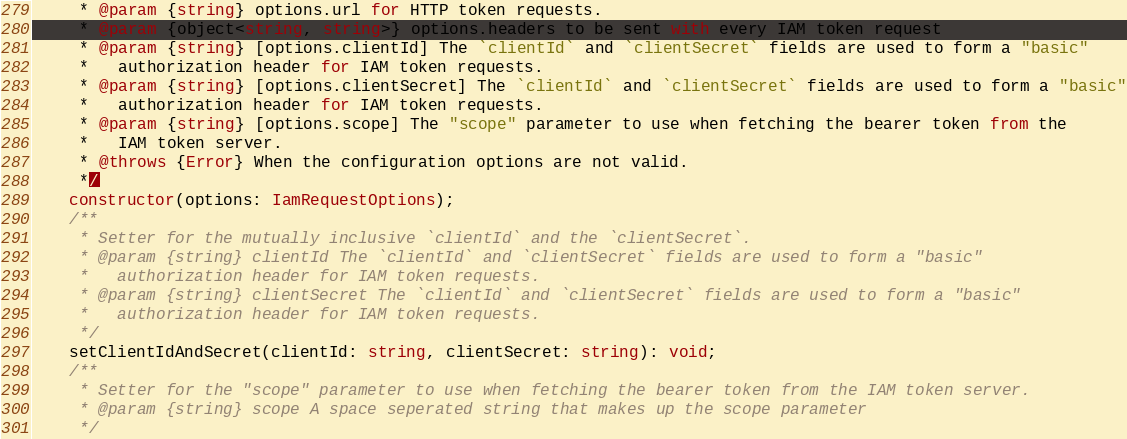Convert code to text. <code><loc_0><loc_0><loc_500><loc_500><_TypeScript_>     * @param {string} options.url for HTTP token requests.
     * @param {object<string, string>} options.headers to be sent with every IAM token request
     * @param {string} [options.clientId] The `clientId` and `clientSecret` fields are used to form a "basic"
     *   authorization header for IAM token requests.
     * @param {string} [options.clientSecret] The `clientId` and `clientSecret` fields are used to form a "basic"
     *   authorization header for IAM token requests.
     * @param {string} [options.scope] The "scope" parameter to use when fetching the bearer token from the
     *   IAM token server.
     * @throws {Error} When the configuration options are not valid.
     */
    constructor(options: IamRequestOptions);
    /**
     * Setter for the mutually inclusive `clientId` and the `clientSecret`.
     * @param {string} clientId The `clientId` and `clientSecret` fields are used to form a "basic"
     *   authorization header for IAM token requests.
     * @param {string} clientSecret The `clientId` and `clientSecret` fields are used to form a "basic"
     *   authorization header for IAM token requests.
     */
    setClientIdAndSecret(clientId: string, clientSecret: string): void;
    /**
     * Setter for the "scope" parameter to use when fetching the bearer token from the IAM token server.
     * @param {string} scope A space seperated string that makes up the scope parameter
     */</code> 